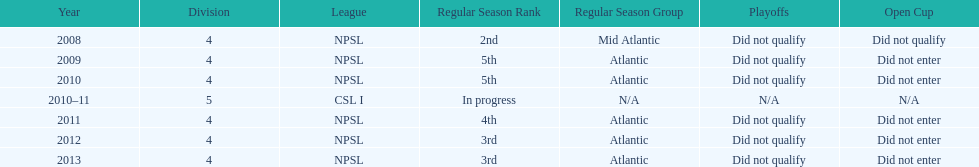How many 3rd place finishes has npsl had? 2. 